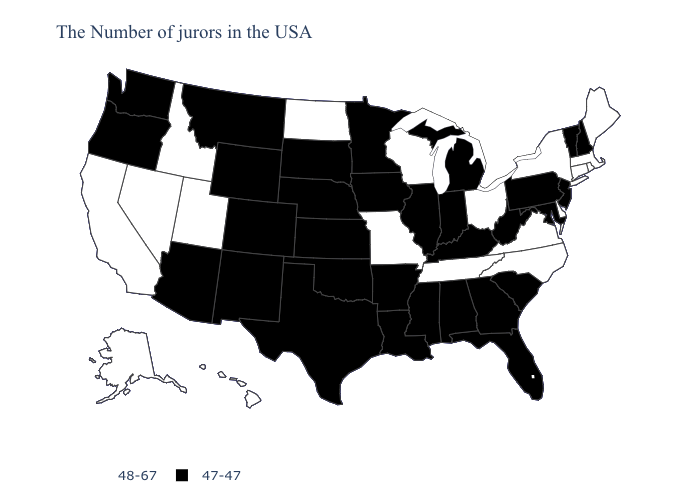Which states hav the highest value in the MidWest?
Answer briefly. Ohio, Wisconsin, Missouri, North Dakota. What is the lowest value in the USA?
Short answer required. 47-47. Name the states that have a value in the range 48-67?
Quick response, please. Maine, Massachusetts, Rhode Island, Connecticut, New York, Delaware, Virginia, North Carolina, Ohio, Tennessee, Wisconsin, Missouri, North Dakota, Utah, Idaho, Nevada, California, Alaska, Hawaii. Name the states that have a value in the range 47-47?
Write a very short answer. New Hampshire, Vermont, New Jersey, Maryland, Pennsylvania, South Carolina, West Virginia, Florida, Georgia, Michigan, Kentucky, Indiana, Alabama, Illinois, Mississippi, Louisiana, Arkansas, Minnesota, Iowa, Kansas, Nebraska, Oklahoma, Texas, South Dakota, Wyoming, Colorado, New Mexico, Montana, Arizona, Washington, Oregon. How many symbols are there in the legend?
Quick response, please. 2. How many symbols are there in the legend?
Quick response, please. 2. What is the value of Wisconsin?
Answer briefly. 48-67. What is the highest value in states that border Minnesota?
Give a very brief answer. 48-67. Does Tennessee have the lowest value in the USA?
Answer briefly. No. Name the states that have a value in the range 47-47?
Keep it brief. New Hampshire, Vermont, New Jersey, Maryland, Pennsylvania, South Carolina, West Virginia, Florida, Georgia, Michigan, Kentucky, Indiana, Alabama, Illinois, Mississippi, Louisiana, Arkansas, Minnesota, Iowa, Kansas, Nebraska, Oklahoma, Texas, South Dakota, Wyoming, Colorado, New Mexico, Montana, Arizona, Washington, Oregon. Name the states that have a value in the range 48-67?
Write a very short answer. Maine, Massachusetts, Rhode Island, Connecticut, New York, Delaware, Virginia, North Carolina, Ohio, Tennessee, Wisconsin, Missouri, North Dakota, Utah, Idaho, Nevada, California, Alaska, Hawaii. What is the value of Michigan?
Write a very short answer. 47-47. What is the value of Ohio?
Answer briefly. 48-67. How many symbols are there in the legend?
Write a very short answer. 2. Does Minnesota have the lowest value in the MidWest?
Give a very brief answer. Yes. 